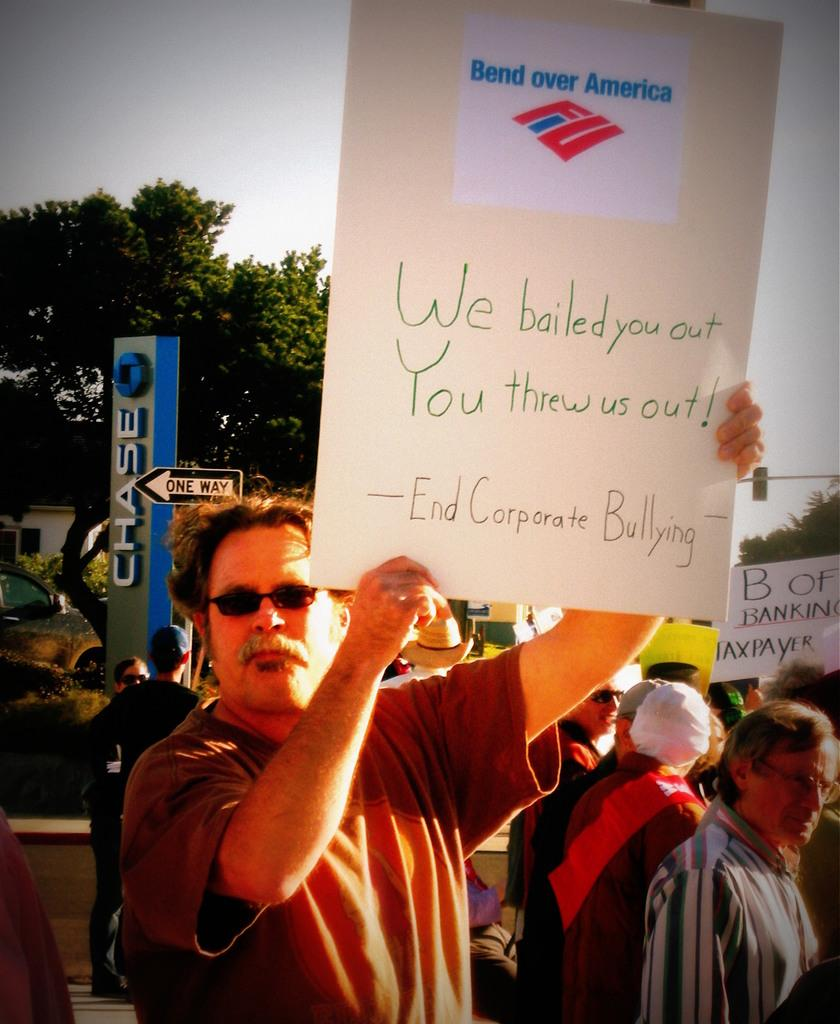What are the people in the image doing? The people in the image are standing. What is the man holding in the image? The man is holding a board in the image. What can be seen in the background of the image? There are boards, trees, a car, a house, and the sky visible in the background of the image. What type of insect can be seen flying around the eggnog in the image? There is no eggnog or insect present in the image. How many cows are visible in the image? There are no cows visible in the image. 